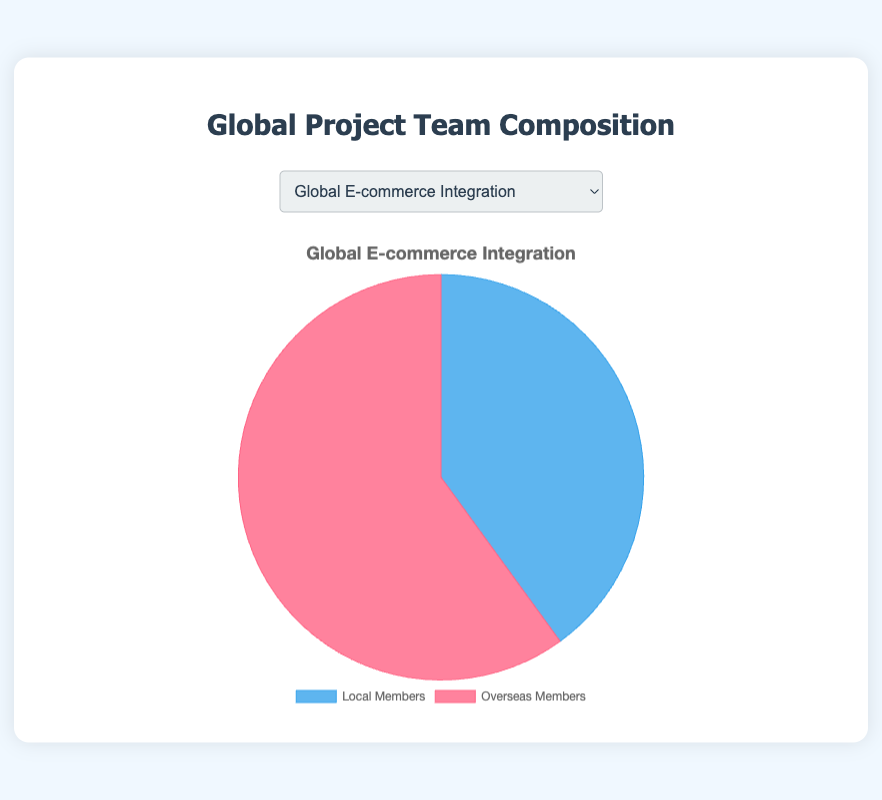What's the proportion of Local Members to Overseas Members in the 'Global E-commerce Integration' project? The project data shows 8 Local Members and 12 Overseas Members. To find the proportion of Local Members to Overseas Members, divide the number of Local Members by the number of Overseas Members: 8/12, which simplifies to 2/3.
Answer: 2/3 Which project has the largest number of Overseas Members compared to Local Members? To determine this, look for where the number of Overseas Members is the greatest relative to Local Members from the provided data. The 'Multilingual Data Analysis Framework' has 13 Overseas Members compared to 6 Local Members, which is the largest difference.
Answer: Multilingual Data Analysis Framework How many more Overseas Members than Local Members are there in the 'AI Customer Support System' project? The project has 5 Local Members and 10 Overseas Members. Calculate the difference by subtracting the number of Local Members from Overseas Members: 10 - 5 = 5.
Answer: 5 What's the total number of team members in the 'Cross-Border Payment Solutions' project? To find the total, add the number of Local Members and Overseas Members: 9 + 11 = 20.
Answer: 20 Are there any projects with an equal number of Local and Overseas Members? Review the data for Local and Overseas Members across all projects. None of the projects have an equal number; each has a different count.
Answer: No How many Overseas Members are there altogether across all projects? Sum the number of Overseas Members across all projects: 12 (Global E-commerce Integration) + 10 (AI Customer Support System) + 9 (International Supply Chain Optimization) + 13 (Multilingual Data Analysis Framework) + 11 (Cross-Border Payment Solutions) = 55.
Answer: 55 If you were to group all Local Members together, how many would there be in total? Sum the number of Local Members across all projects: 8 (Global E-commerce Integration) + 5 (AI Customer Support System) + 7 (International Supply Chain Optimization) + 6 (Multilingual Data Analysis Framework) + 9 (Cross-Border Payment Solutions) = 35.
Answer: 35 